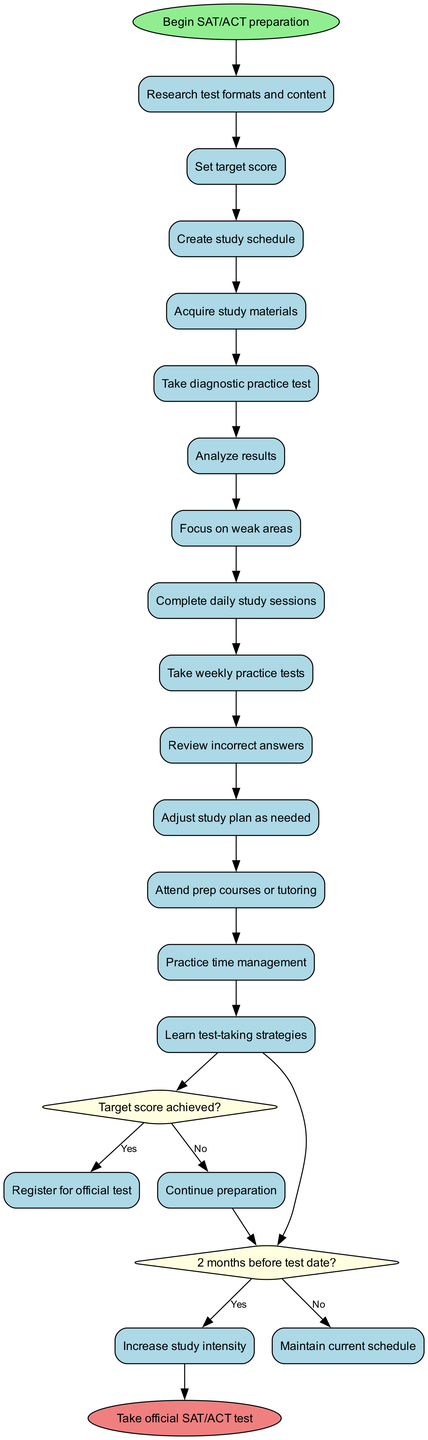What is the starting node for SAT/ACT preparation? The starting node, as indicated in the diagram, is "Begin SAT/ACT preparation". It is the initial point from which all activities and decisions stem.
Answer: Begin SAT/ACT preparation How many activities are listed in the diagram? The diagram includes a total of 13 activities that outline steps in the preparation process for the SAT/ACT. Each activity is connected sequentially, forming a flow of preparation activities.
Answer: 13 What is the first activity after the start node? The first activity after the start node is "Research test formats and content". This activity directly follows the starting point and is crucial for understanding what to expect in the test.
Answer: Research test formats and content What happens if the target score is not achieved? If the target score is not achieved, the next step is to "Continue preparation". This step is directly linked to the decision node questioning whether the target score has been reached, indicating a loop back into further study.
Answer: Continue preparation What action must be taken two months before the test date? Two months before the test date, the preparation intensity should be "Increased study intensity". This decision highlights a critical time frame when study efforts may need to be amplified for better results.
Answer: Increase study intensity Which activity is directly before the decision node questioning the target score? The activity directly before the decision node about the target score is "Review incorrect answers". This activity emphasizes the importance of reflecting on practice test mistakes before evaluating overall test preparation success.
Answer: Review incorrect answers What is the last activity before taking the official test? The last activity before taking the official test is "Register for official test". This indicates the culmination of all preparation efforts and planning, leading up to the final step of taking the SAT/ACT.
Answer: Register for official test If the answer to the question about the target score is yes, what is the next step? If the answer to whether the target score is achieved is yes, the next step is to "Register for official test". This event marks a successful conclusion to the preparation timeline.
Answer: Register for official test What should be done if it is not two months before the test date? If it is not two months before the test date, then one should "Maintain current schedule". This implies a continuation of the existing study plan without any need for escalation or changes.
Answer: Maintain current schedule 